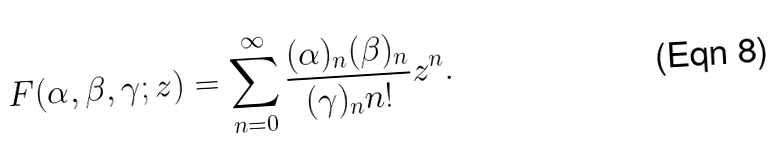<formula> <loc_0><loc_0><loc_500><loc_500>F ( \alpha , \beta , \gamma ; z ) = \sum _ { n = 0 } ^ { \infty } \frac { ( \alpha ) _ { n } ( \beta ) _ { n } } { ( \gamma ) _ { n } n ! } z ^ { n } .</formula> 